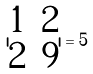<formula> <loc_0><loc_0><loc_500><loc_500>| \begin{matrix} 1 & 2 \\ 2 & 9 \\ \end{matrix} | = 5</formula> 